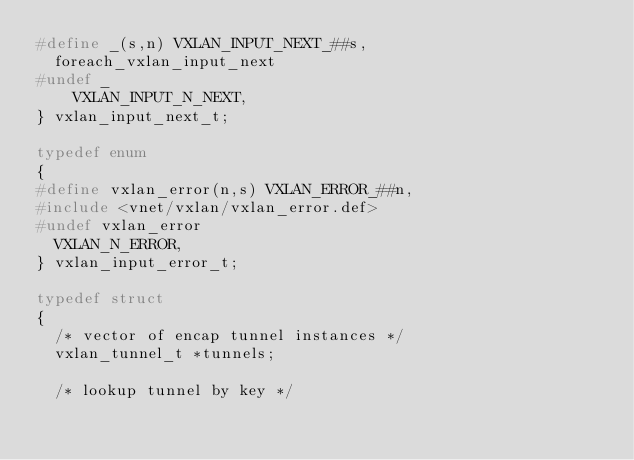<code> <loc_0><loc_0><loc_500><loc_500><_C_>#define _(s,n) VXLAN_INPUT_NEXT_##s,
  foreach_vxlan_input_next
#undef _
    VXLAN_INPUT_N_NEXT,
} vxlan_input_next_t;

typedef enum
{
#define vxlan_error(n,s) VXLAN_ERROR_##n,
#include <vnet/vxlan/vxlan_error.def>
#undef vxlan_error
  VXLAN_N_ERROR,
} vxlan_input_error_t;

typedef struct
{
  /* vector of encap tunnel instances */
  vxlan_tunnel_t *tunnels;

  /* lookup tunnel by key */</code> 